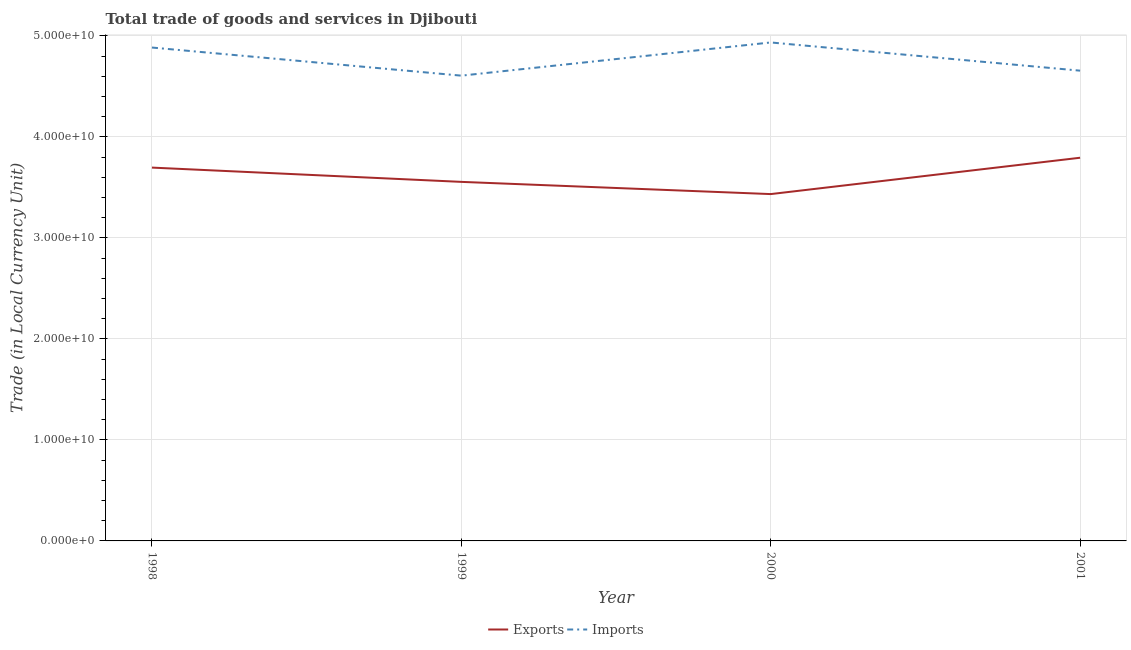How many different coloured lines are there?
Keep it short and to the point. 2. Is the number of lines equal to the number of legend labels?
Keep it short and to the point. Yes. What is the export of goods and services in 1998?
Provide a short and direct response. 3.70e+1. Across all years, what is the maximum imports of goods and services?
Provide a short and direct response. 4.94e+1. Across all years, what is the minimum imports of goods and services?
Make the answer very short. 4.61e+1. In which year was the export of goods and services minimum?
Keep it short and to the point. 2000. What is the total export of goods and services in the graph?
Your response must be concise. 1.45e+11. What is the difference between the imports of goods and services in 1999 and that in 2001?
Give a very brief answer. -4.94e+08. What is the difference between the imports of goods and services in 2001 and the export of goods and services in 1999?
Provide a succinct answer. 1.10e+1. What is the average imports of goods and services per year?
Provide a short and direct response. 4.77e+1. In the year 2000, what is the difference between the imports of goods and services and export of goods and services?
Make the answer very short. 1.50e+1. What is the ratio of the imports of goods and services in 1998 to that in 1999?
Keep it short and to the point. 1.06. What is the difference between the highest and the second highest imports of goods and services?
Give a very brief answer. 5.03e+08. What is the difference between the highest and the lowest imports of goods and services?
Offer a terse response. 3.29e+09. In how many years, is the export of goods and services greater than the average export of goods and services taken over all years?
Your answer should be very brief. 2. Does the imports of goods and services monotonically increase over the years?
Give a very brief answer. No. Is the imports of goods and services strictly less than the export of goods and services over the years?
Give a very brief answer. No. How many lines are there?
Provide a succinct answer. 2. Are the values on the major ticks of Y-axis written in scientific E-notation?
Your answer should be very brief. Yes. Does the graph contain grids?
Offer a very short reply. Yes. What is the title of the graph?
Offer a very short reply. Total trade of goods and services in Djibouti. Does "Rural" appear as one of the legend labels in the graph?
Make the answer very short. No. What is the label or title of the X-axis?
Give a very brief answer. Year. What is the label or title of the Y-axis?
Offer a very short reply. Trade (in Local Currency Unit). What is the Trade (in Local Currency Unit) of Exports in 1998?
Your answer should be compact. 3.70e+1. What is the Trade (in Local Currency Unit) of Imports in 1998?
Offer a terse response. 4.89e+1. What is the Trade (in Local Currency Unit) in Exports in 1999?
Offer a terse response. 3.56e+1. What is the Trade (in Local Currency Unit) in Imports in 1999?
Give a very brief answer. 4.61e+1. What is the Trade (in Local Currency Unit) in Exports in 2000?
Offer a terse response. 3.43e+1. What is the Trade (in Local Currency Unit) of Imports in 2000?
Offer a terse response. 4.94e+1. What is the Trade (in Local Currency Unit) of Exports in 2001?
Ensure brevity in your answer.  3.79e+1. What is the Trade (in Local Currency Unit) of Imports in 2001?
Make the answer very short. 4.66e+1. Across all years, what is the maximum Trade (in Local Currency Unit) of Exports?
Your answer should be compact. 3.79e+1. Across all years, what is the maximum Trade (in Local Currency Unit) in Imports?
Give a very brief answer. 4.94e+1. Across all years, what is the minimum Trade (in Local Currency Unit) of Exports?
Ensure brevity in your answer.  3.43e+1. Across all years, what is the minimum Trade (in Local Currency Unit) of Imports?
Make the answer very short. 4.61e+1. What is the total Trade (in Local Currency Unit) in Exports in the graph?
Provide a short and direct response. 1.45e+11. What is the total Trade (in Local Currency Unit) in Imports in the graph?
Your answer should be compact. 1.91e+11. What is the difference between the Trade (in Local Currency Unit) of Exports in 1998 and that in 1999?
Offer a very short reply. 1.41e+09. What is the difference between the Trade (in Local Currency Unit) of Imports in 1998 and that in 1999?
Give a very brief answer. 2.78e+09. What is the difference between the Trade (in Local Currency Unit) of Exports in 1998 and that in 2000?
Your answer should be compact. 2.62e+09. What is the difference between the Trade (in Local Currency Unit) of Imports in 1998 and that in 2000?
Your response must be concise. -5.03e+08. What is the difference between the Trade (in Local Currency Unit) of Exports in 1998 and that in 2001?
Your response must be concise. -9.75e+08. What is the difference between the Trade (in Local Currency Unit) in Imports in 1998 and that in 2001?
Provide a short and direct response. 2.29e+09. What is the difference between the Trade (in Local Currency Unit) in Exports in 1999 and that in 2000?
Give a very brief answer. 1.21e+09. What is the difference between the Trade (in Local Currency Unit) in Imports in 1999 and that in 2000?
Ensure brevity in your answer.  -3.29e+09. What is the difference between the Trade (in Local Currency Unit) of Exports in 1999 and that in 2001?
Provide a short and direct response. -2.39e+09. What is the difference between the Trade (in Local Currency Unit) of Imports in 1999 and that in 2001?
Provide a short and direct response. -4.94e+08. What is the difference between the Trade (in Local Currency Unit) of Exports in 2000 and that in 2001?
Keep it short and to the point. -3.60e+09. What is the difference between the Trade (in Local Currency Unit) of Imports in 2000 and that in 2001?
Ensure brevity in your answer.  2.79e+09. What is the difference between the Trade (in Local Currency Unit) of Exports in 1998 and the Trade (in Local Currency Unit) of Imports in 1999?
Make the answer very short. -9.10e+09. What is the difference between the Trade (in Local Currency Unit) in Exports in 1998 and the Trade (in Local Currency Unit) in Imports in 2000?
Make the answer very short. -1.24e+1. What is the difference between the Trade (in Local Currency Unit) of Exports in 1998 and the Trade (in Local Currency Unit) of Imports in 2001?
Provide a short and direct response. -9.60e+09. What is the difference between the Trade (in Local Currency Unit) in Exports in 1999 and the Trade (in Local Currency Unit) in Imports in 2000?
Ensure brevity in your answer.  -1.38e+1. What is the difference between the Trade (in Local Currency Unit) in Exports in 1999 and the Trade (in Local Currency Unit) in Imports in 2001?
Offer a very short reply. -1.10e+1. What is the difference between the Trade (in Local Currency Unit) in Exports in 2000 and the Trade (in Local Currency Unit) in Imports in 2001?
Give a very brief answer. -1.22e+1. What is the average Trade (in Local Currency Unit) in Exports per year?
Provide a short and direct response. 3.62e+1. What is the average Trade (in Local Currency Unit) of Imports per year?
Your response must be concise. 4.77e+1. In the year 1998, what is the difference between the Trade (in Local Currency Unit) in Exports and Trade (in Local Currency Unit) in Imports?
Make the answer very short. -1.19e+1. In the year 1999, what is the difference between the Trade (in Local Currency Unit) in Exports and Trade (in Local Currency Unit) in Imports?
Your response must be concise. -1.05e+1. In the year 2000, what is the difference between the Trade (in Local Currency Unit) in Exports and Trade (in Local Currency Unit) in Imports?
Provide a succinct answer. -1.50e+1. In the year 2001, what is the difference between the Trade (in Local Currency Unit) in Exports and Trade (in Local Currency Unit) in Imports?
Keep it short and to the point. -8.62e+09. What is the ratio of the Trade (in Local Currency Unit) in Exports in 1998 to that in 1999?
Make the answer very short. 1.04. What is the ratio of the Trade (in Local Currency Unit) of Imports in 1998 to that in 1999?
Offer a terse response. 1.06. What is the ratio of the Trade (in Local Currency Unit) of Exports in 1998 to that in 2000?
Your answer should be very brief. 1.08. What is the ratio of the Trade (in Local Currency Unit) in Imports in 1998 to that in 2000?
Make the answer very short. 0.99. What is the ratio of the Trade (in Local Currency Unit) of Exports in 1998 to that in 2001?
Provide a succinct answer. 0.97. What is the ratio of the Trade (in Local Currency Unit) of Imports in 1998 to that in 2001?
Your answer should be very brief. 1.05. What is the ratio of the Trade (in Local Currency Unit) in Exports in 1999 to that in 2000?
Ensure brevity in your answer.  1.04. What is the ratio of the Trade (in Local Currency Unit) of Imports in 1999 to that in 2000?
Provide a succinct answer. 0.93. What is the ratio of the Trade (in Local Currency Unit) of Exports in 1999 to that in 2001?
Offer a very short reply. 0.94. What is the ratio of the Trade (in Local Currency Unit) in Imports in 1999 to that in 2001?
Ensure brevity in your answer.  0.99. What is the ratio of the Trade (in Local Currency Unit) in Exports in 2000 to that in 2001?
Offer a terse response. 0.91. What is the ratio of the Trade (in Local Currency Unit) of Imports in 2000 to that in 2001?
Your answer should be compact. 1.06. What is the difference between the highest and the second highest Trade (in Local Currency Unit) in Exports?
Ensure brevity in your answer.  9.75e+08. What is the difference between the highest and the second highest Trade (in Local Currency Unit) in Imports?
Provide a succinct answer. 5.03e+08. What is the difference between the highest and the lowest Trade (in Local Currency Unit) of Exports?
Provide a short and direct response. 3.60e+09. What is the difference between the highest and the lowest Trade (in Local Currency Unit) in Imports?
Make the answer very short. 3.29e+09. 